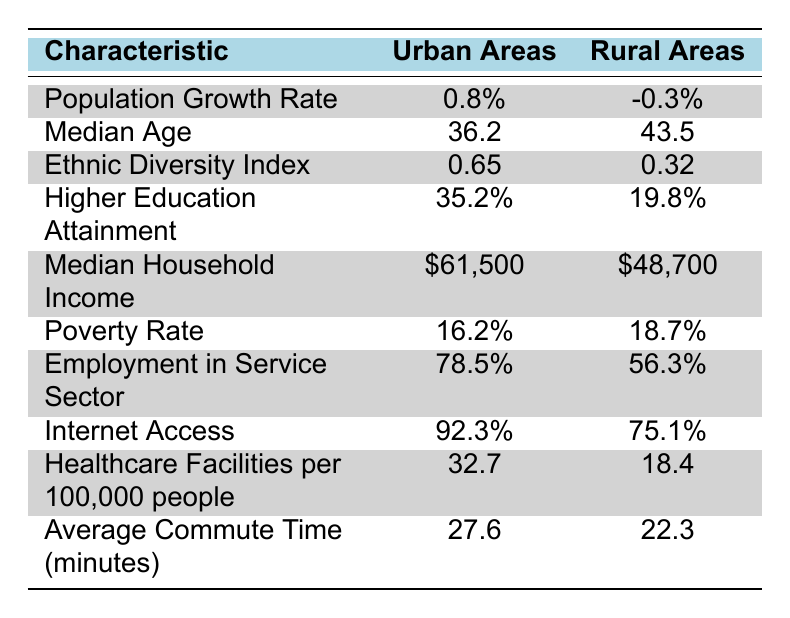What is the population growth rate in urban areas? The table lists the population growth rate specifically for urban areas as 0.8%.
Answer: 0.8% What is the median age of individuals living in rural areas? According to the table, the median age in rural areas is provided as 43.5.
Answer: 43.5 Is the poverty rate higher in urban or rural areas? The table shows a poverty rate of 16.2% in urban areas and 18.7% in rural areas. Since 18.7% is greater than 16.2%, the poverty rate is higher in rural areas.
Answer: Yes, rural areas have a higher poverty rate What is the difference in median household income between urban and rural areas? From the table, the median household income in urban areas is $61,500 and in rural areas, it is $48,700. The difference is calculated as $61,500 - $48,700 = $12,800.
Answer: $12,800 What percentage of the workforce is employed in the service sector in urban areas? The table indicates that 78.5% of employment in urban areas is in the service sector.
Answer: 78.5% What is the average of the Ethnic Diversity Index for both urban and rural areas? The Ethnic Diversity Index for urban areas is 0.65 and for rural areas, it is 0.32. To find the average, we sum these values: 0.65 + 0.32 = 0.97, and then divide by 2: 0.97 / 2 = 0.485.
Answer: 0.485 How many more healthcare facilities per 100,000 people are there in urban areas compared to rural areas? The table reveals that there are 32.7 healthcare facilities in urban areas and 18.4 in rural areas. The difference is calculated as 32.7 - 18.4 = 14.3 facilities.
Answer: 14.3 Is internet access greater in urban areas than in rural areas? The table states that urban areas have an internet access rate of 92.3%, while rural areas have 75.1%. Since 92.3% is greater than 75.1%, internet access is indeed greater in urban areas.
Answer: Yes What is the average commute time for urban areas? The table lists the average commute time in urban areas as 27.6 minutes.
Answer: 27.6 minutes 